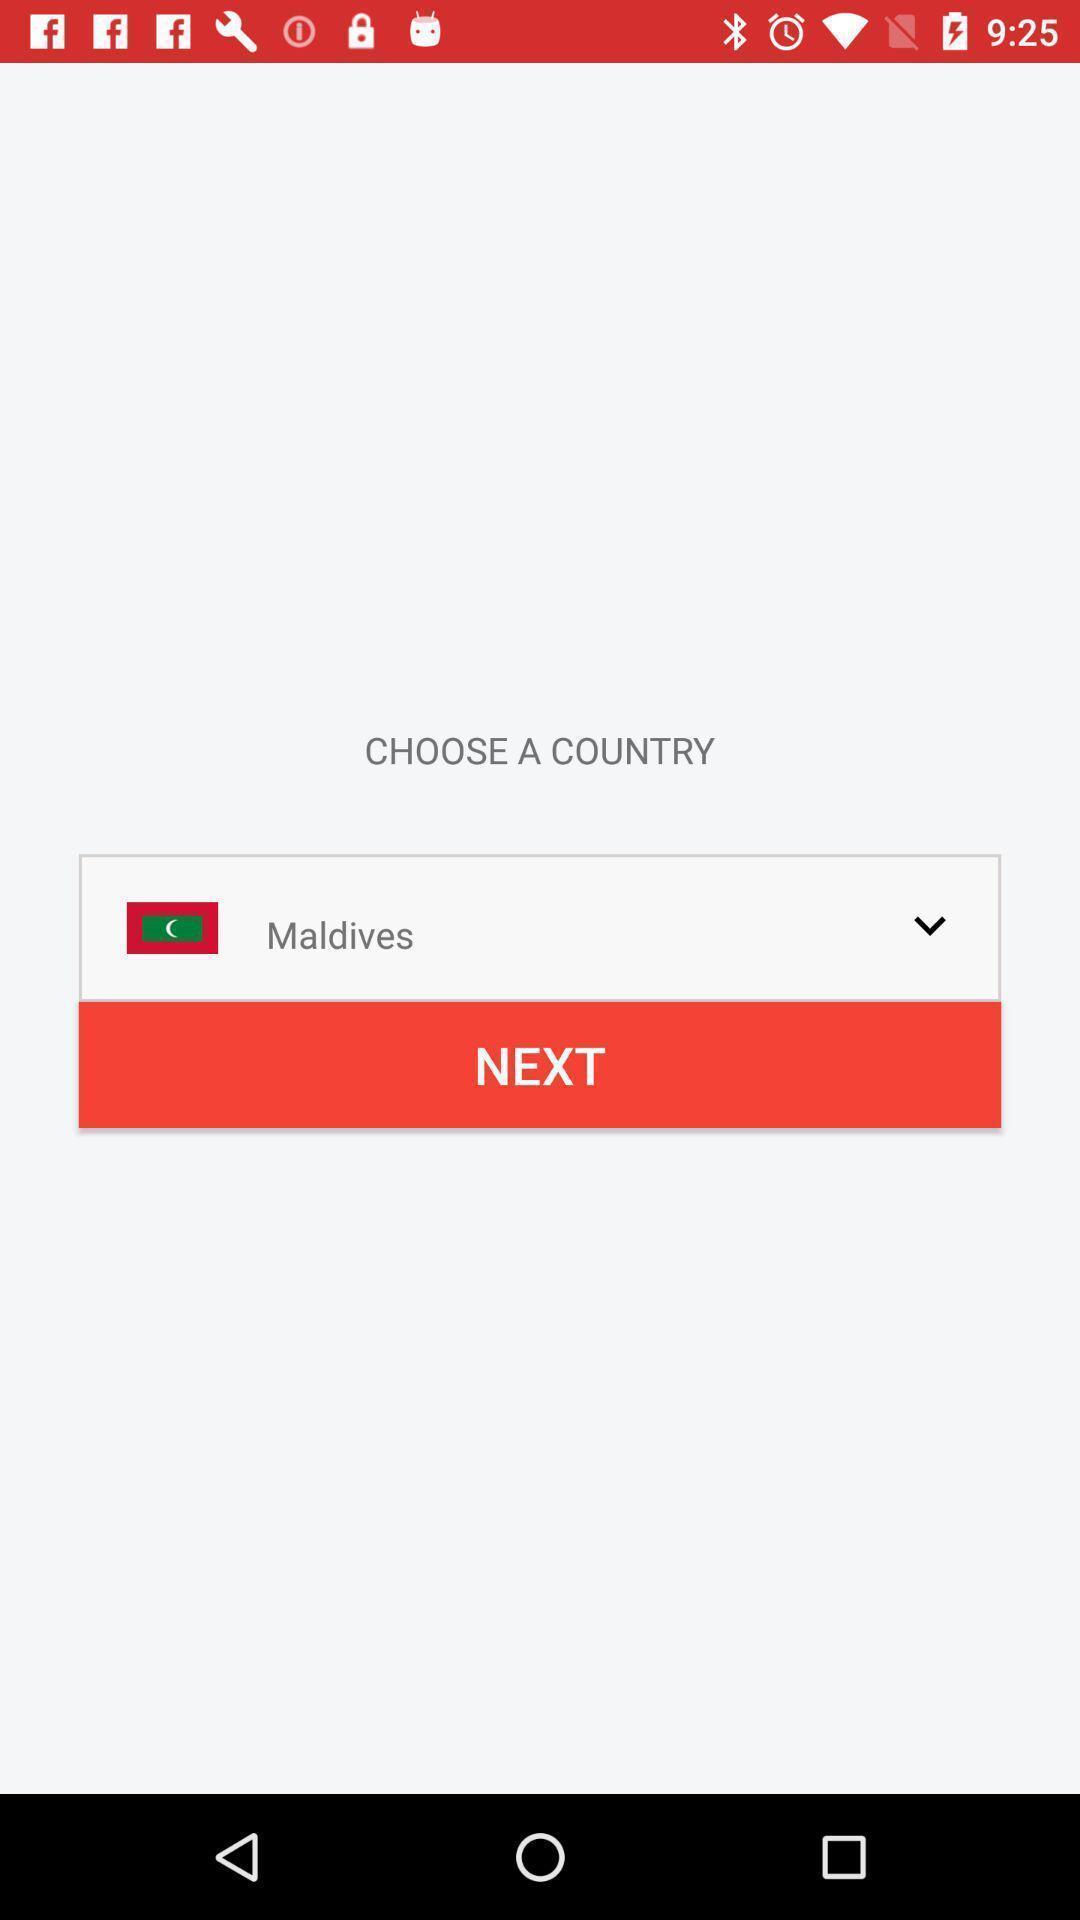Summarize the main components in this picture. Page for choosing a country for an app. 